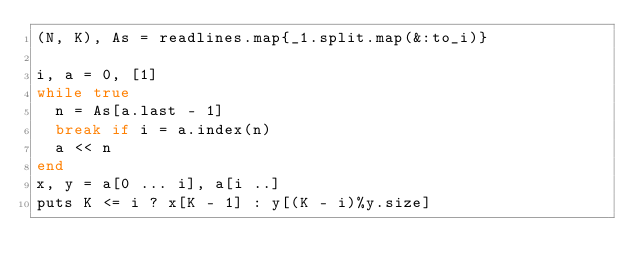<code> <loc_0><loc_0><loc_500><loc_500><_Ruby_>(N, K), As = readlines.map{_1.split.map(&:to_i)}

i, a = 0, [1]
while true
  n = As[a.last - 1]
  break if i = a.index(n)
  a << n
end
x, y = a[0 ... i], a[i ..]
puts K <= i ? x[K - 1] : y[(K - i)%y.size]</code> 